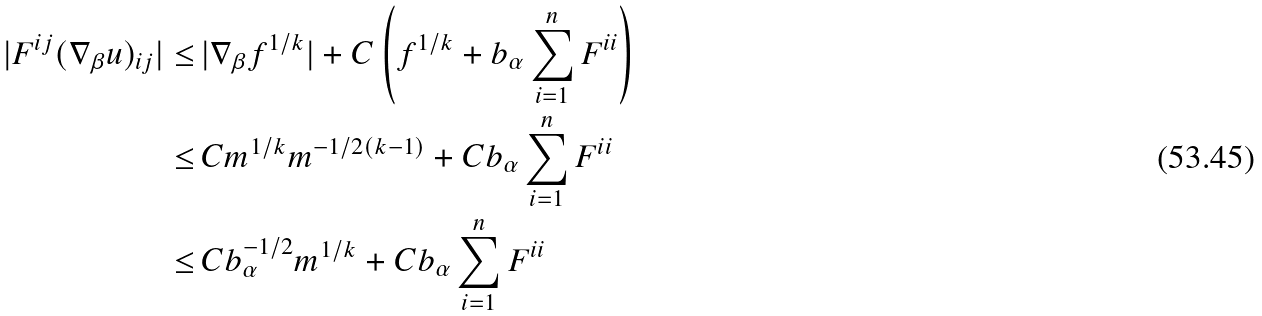Convert formula to latex. <formula><loc_0><loc_0><loc_500><loc_500>| F ^ { i j } ( \nabla _ { \beta } u ) _ { i j } | \leq \, & | \nabla _ { \beta } f ^ { 1 / k } | + C \left ( f ^ { 1 / k } + b _ { \alpha } \sum _ { i = 1 } ^ { n } F ^ { i i } \right ) \\ \leq \, & C m ^ { 1 / k } m ^ { - 1 / 2 ( k - 1 ) } + C b _ { \alpha } \sum _ { i = 1 } ^ { n } F ^ { i i } \\ \leq \, & C b _ { \alpha } ^ { - 1 / 2 } m ^ { 1 / k } + C b _ { \alpha } \sum _ { i = 1 } ^ { n } F ^ { i i }</formula> 